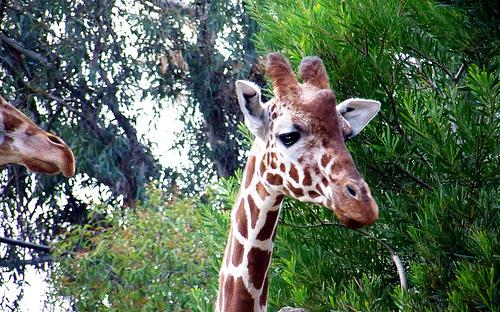Provide a succinct summary of the main object in the picture. A tall, spotted giraffe stands outdoors next to a tree. Mention the primary animal in the photo and its appearance. A tall giraffe with brown and white spots and a long neck is standing outside. State the primary animal in the image and its activity. A tall giraffe is standing outside, adjacent to a tree. Illustrate the centerpiece of this image, mentioning any unusual features. The image showcases a tall giraffe with a striking pattern of brown and white spots, standing tall next to a tree. Explain briefly what the main subject of the image is and what it is doing. A tall giraffe is standing outside near a tree with its long neck and spotted body. What is the main creature in the image and what is its notable feature? The main creature is a giraffe with a long neck and brown and white spots. Discuss the central object in the image and its surroundings. A tall giraffe stands prominently next to a tree, its long neck and patterned spots harmonizing with the outdoor environment. Highlight the foremost being in the picture and any remarkable traits. A tall giraffe, exhibiting a distinct long neck and spotted coat, stands proudly outdoors. Elaborate on the primary being in the image and its environment. A majestic, tall giraffe stands next to a foliage-rich tree, displaying its unique pattern of brown and white spots. Describe the most important figure in the image, along with any surrounding elements. A tall giraffe stands by a tree, showcasing its long neck and distinctive pattern of spots. 